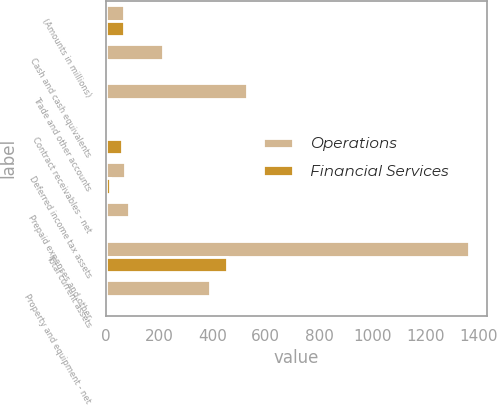Convert chart. <chart><loc_0><loc_0><loc_500><loc_500><stacked_bar_chart><ecel><fcel>(Amounts in millions)<fcel>Cash and cash equivalents<fcel>Trade and other accounts<fcel>Contract receivables - net<fcel>Deferred income tax assets<fcel>Prepaid expenses and other<fcel>Total current assets<fcel>Property and equipment - net<nl><fcel>Operations<fcel>66.25<fcel>214.4<fcel>531.1<fcel>7<fcel>71.1<fcel>88.1<fcel>1361.4<fcel>390.9<nl><fcel>Financial Services<fcel>66.25<fcel>3.2<fcel>0.5<fcel>61.4<fcel>14.3<fcel>1.3<fcel>455.3<fcel>1.6<nl></chart> 